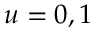Convert formula to latex. <formula><loc_0><loc_0><loc_500><loc_500>u = 0 , 1</formula> 